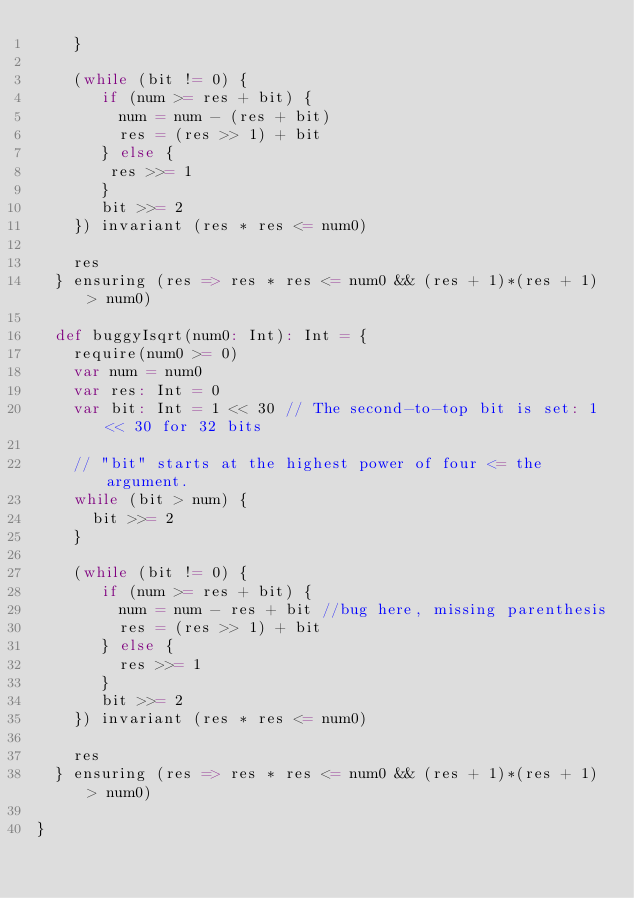<code> <loc_0><loc_0><loc_500><loc_500><_Scala_>    }

    (while (bit != 0) {
       if (num >= res + bit) {
         num = num - (res + bit)
         res = (res >> 1) + bit
       } else {
        res >>= 1
       }
       bit >>= 2
    }) invariant (res * res <= num0)

    res
  } ensuring (res => res * res <= num0 && (res + 1)*(res + 1) > num0) 

  def buggyIsqrt(num0: Int): Int = {
    require(num0 >= 0)
    var num = num0
    var res: Int = 0
    var bit: Int = 1 << 30 // The second-to-top bit is set: 1 << 30 for 32 bits
  
    // "bit" starts at the highest power of four <= the argument.
    while (bit > num) {
      bit >>= 2
    }

    (while (bit != 0) {
       if (num >= res + bit) {
         num = num - res + bit //bug here, missing parenthesis
         res = (res >> 1) + bit
       } else {
         res >>= 1
       }
       bit >>= 2
    }) invariant (res * res <= num0)

    res
  } ensuring (res => res * res <= num0 && (res + 1)*(res + 1) > num0) 

}
</code> 